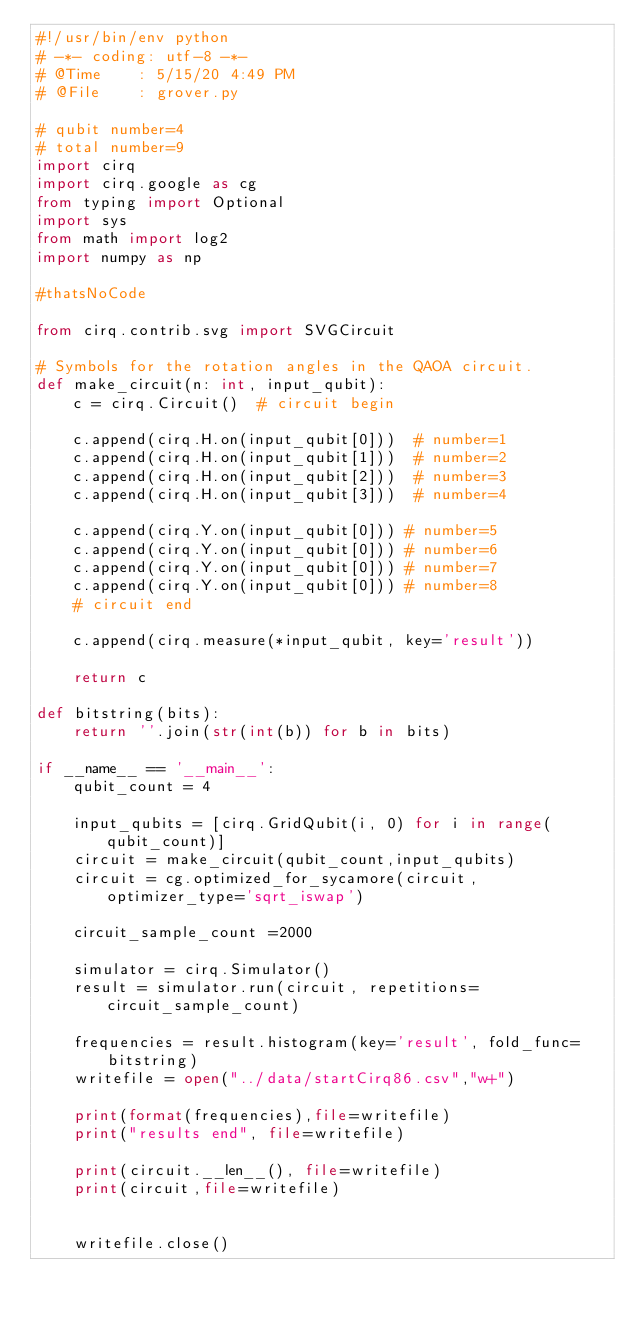Convert code to text. <code><loc_0><loc_0><loc_500><loc_500><_Python_>#!/usr/bin/env python
# -*- coding: utf-8 -*-
# @Time    : 5/15/20 4:49 PM
# @File    : grover.py

# qubit number=4
# total number=9
import cirq
import cirq.google as cg
from typing import Optional
import sys
from math import log2
import numpy as np

#thatsNoCode

from cirq.contrib.svg import SVGCircuit

# Symbols for the rotation angles in the QAOA circuit.
def make_circuit(n: int, input_qubit):
    c = cirq.Circuit()  # circuit begin

    c.append(cirq.H.on(input_qubit[0]))  # number=1
    c.append(cirq.H.on(input_qubit[1]))  # number=2
    c.append(cirq.H.on(input_qubit[2]))  # number=3
    c.append(cirq.H.on(input_qubit[3]))  # number=4

    c.append(cirq.Y.on(input_qubit[0])) # number=5
    c.append(cirq.Y.on(input_qubit[0])) # number=6
    c.append(cirq.Y.on(input_qubit[0])) # number=7
    c.append(cirq.Y.on(input_qubit[0])) # number=8
    # circuit end

    c.append(cirq.measure(*input_qubit, key='result'))

    return c

def bitstring(bits):
    return ''.join(str(int(b)) for b in bits)

if __name__ == '__main__':
    qubit_count = 4

    input_qubits = [cirq.GridQubit(i, 0) for i in range(qubit_count)]
    circuit = make_circuit(qubit_count,input_qubits)
    circuit = cg.optimized_for_sycamore(circuit, optimizer_type='sqrt_iswap')

    circuit_sample_count =2000

    simulator = cirq.Simulator()
    result = simulator.run(circuit, repetitions=circuit_sample_count)

    frequencies = result.histogram(key='result', fold_func=bitstring)
    writefile = open("../data/startCirq86.csv","w+")

    print(format(frequencies),file=writefile)
    print("results end", file=writefile)

    print(circuit.__len__(), file=writefile)
    print(circuit,file=writefile)


    writefile.close()</code> 